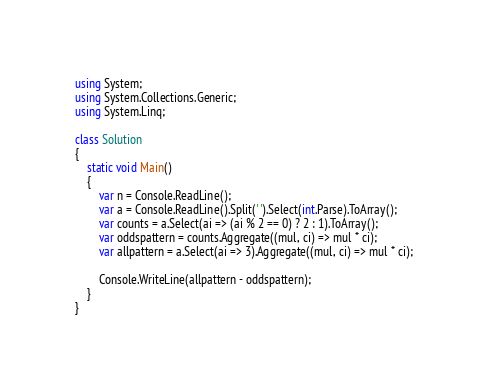<code> <loc_0><loc_0><loc_500><loc_500><_C#_>using System;
using System.Collections.Generic;
using System.Linq;

class Solution
{
    static void Main()
    {
        var n = Console.ReadLine();
        var a = Console.ReadLine().Split(' ').Select(int.Parse).ToArray();
        var counts = a.Select(ai => (ai % 2 == 0) ? 2 : 1).ToArray();
        var oddspattern = counts.Aggregate((mul, ci) => mul * ci);
        var allpattern = a.Select(ai => 3).Aggregate((mul, ci) => mul * ci);

        Console.WriteLine(allpattern - oddspattern);
    }
}</code> 